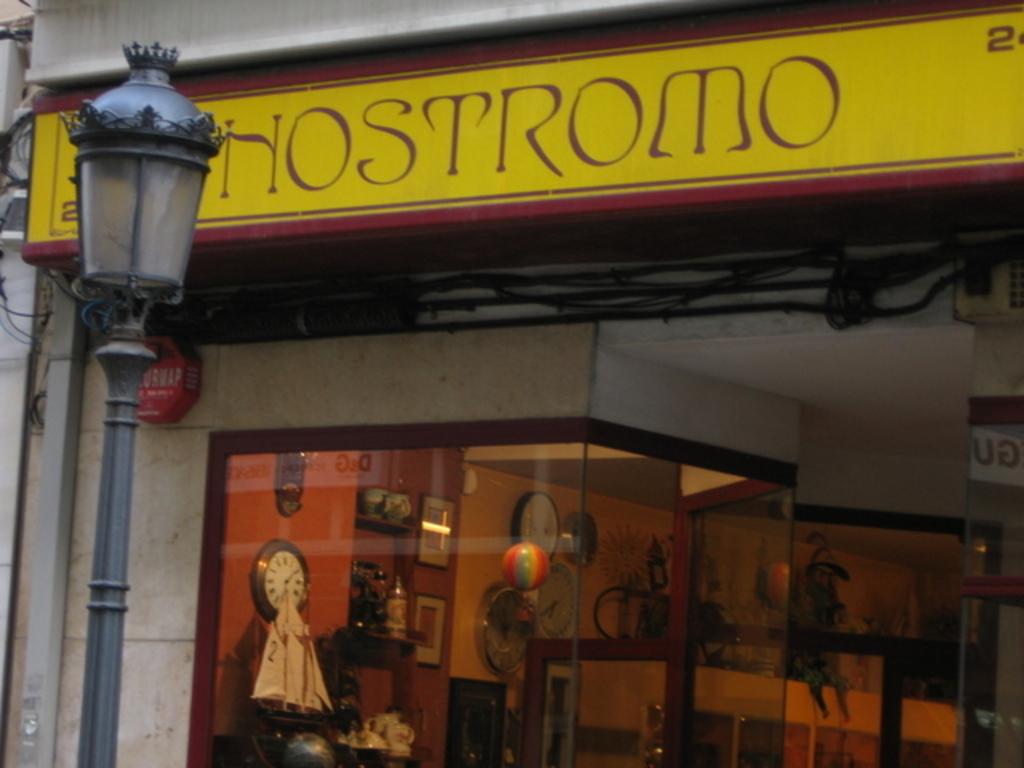What is listed on the store sign?
Make the answer very short. Hostromo. What is the title of this store?
Offer a terse response. Hostromo. 